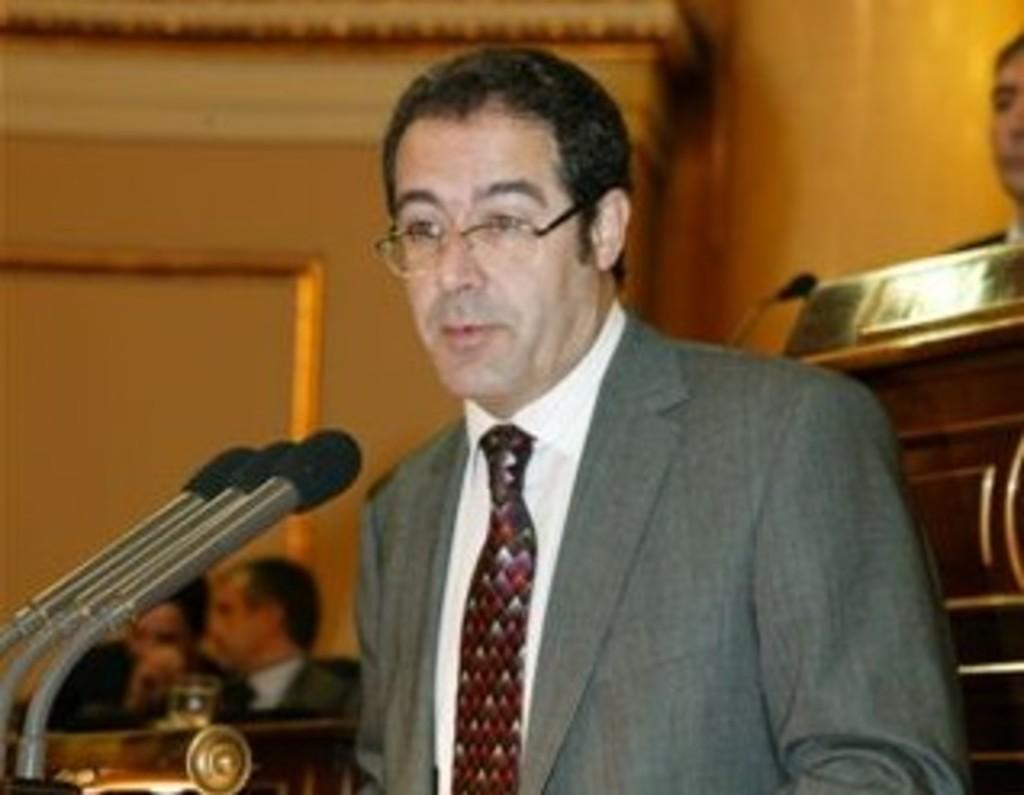How many people are in the image? There is a group of people in the image. Can you describe the man in the middle of the image? The man in the middle of the image is wearing spectacles. What objects are in front of the man? There are microphones in front of the man. What type of nest can be seen in the image? There is no nest present in the image. How does the man's digestion appear to be in the image? The image does not show the man's digestion, so it cannot be determined from the image. 